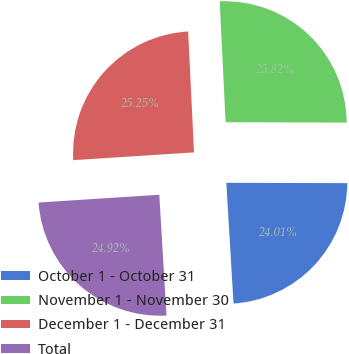Convert chart. <chart><loc_0><loc_0><loc_500><loc_500><pie_chart><fcel>October 1 - October 31<fcel>November 1 - November 30<fcel>December 1 - December 31<fcel>Total<nl><fcel>24.01%<fcel>25.82%<fcel>25.25%<fcel>24.92%<nl></chart> 